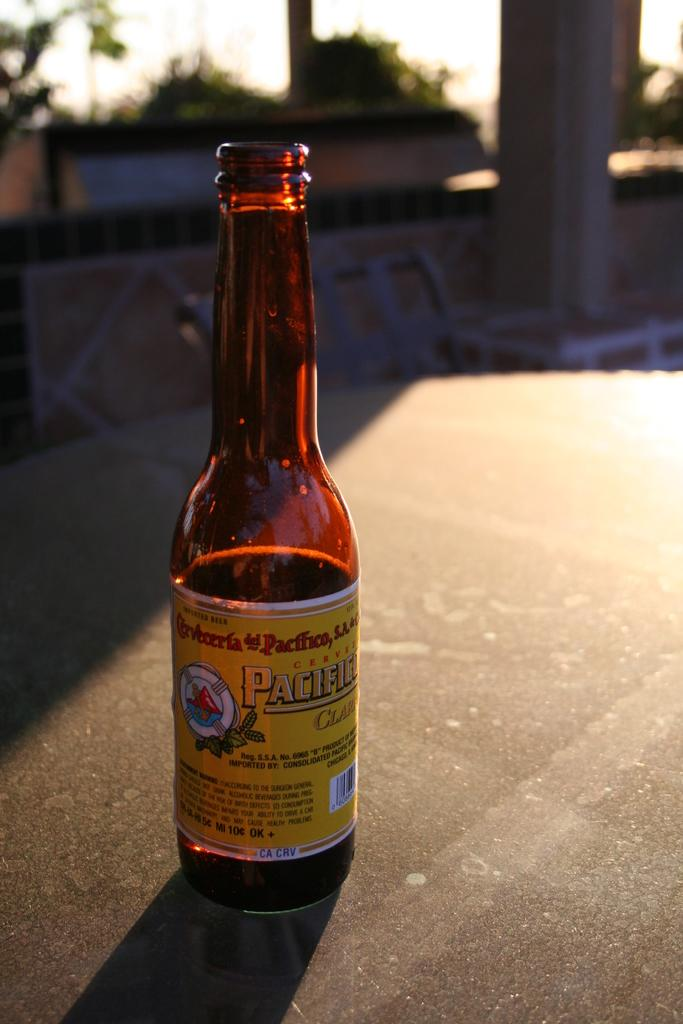Provide a one-sentence caption for the provided image. A returnable glass bottle of imported Cerveza sits on a table in the sun. 